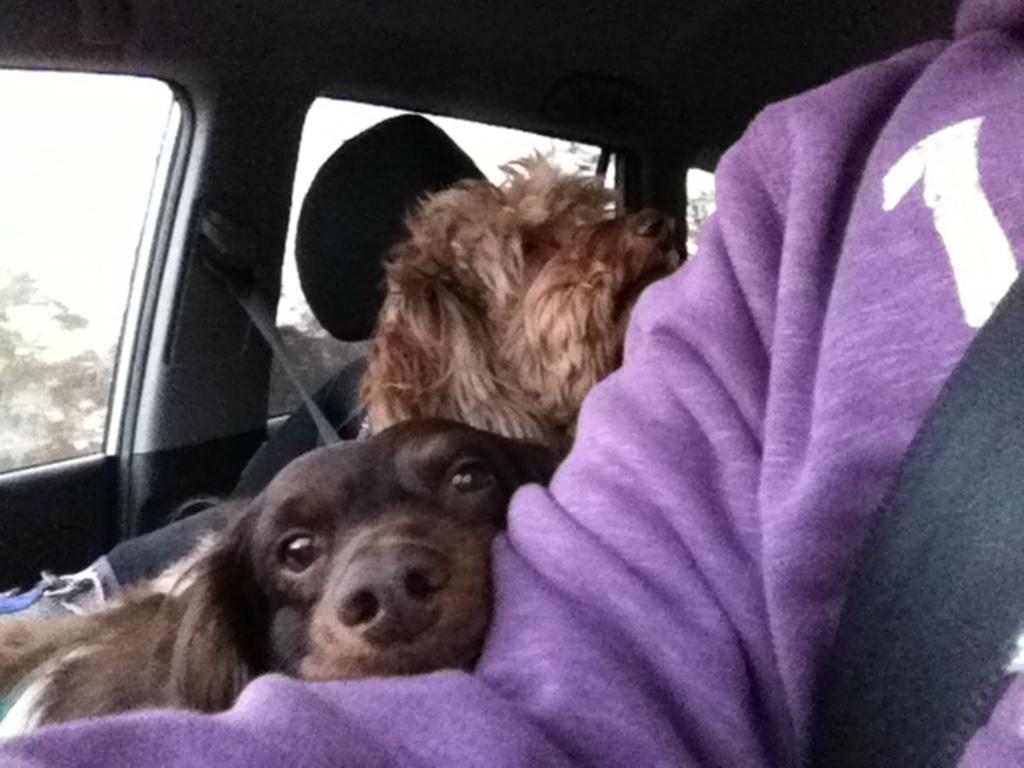How would you summarize this image in a sentence or two? In this image there is a person sitting inside the car and he is wearing a seat belt. Beside him there are two dogs sitting on the seat. There are glass windows through which we can see the trees and sky. 